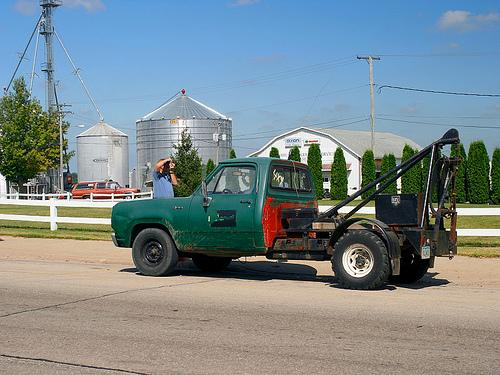What color was this truck originally? Please explain your reasoning. red. It's seen at the back of the cab where it wasn't repainted. 